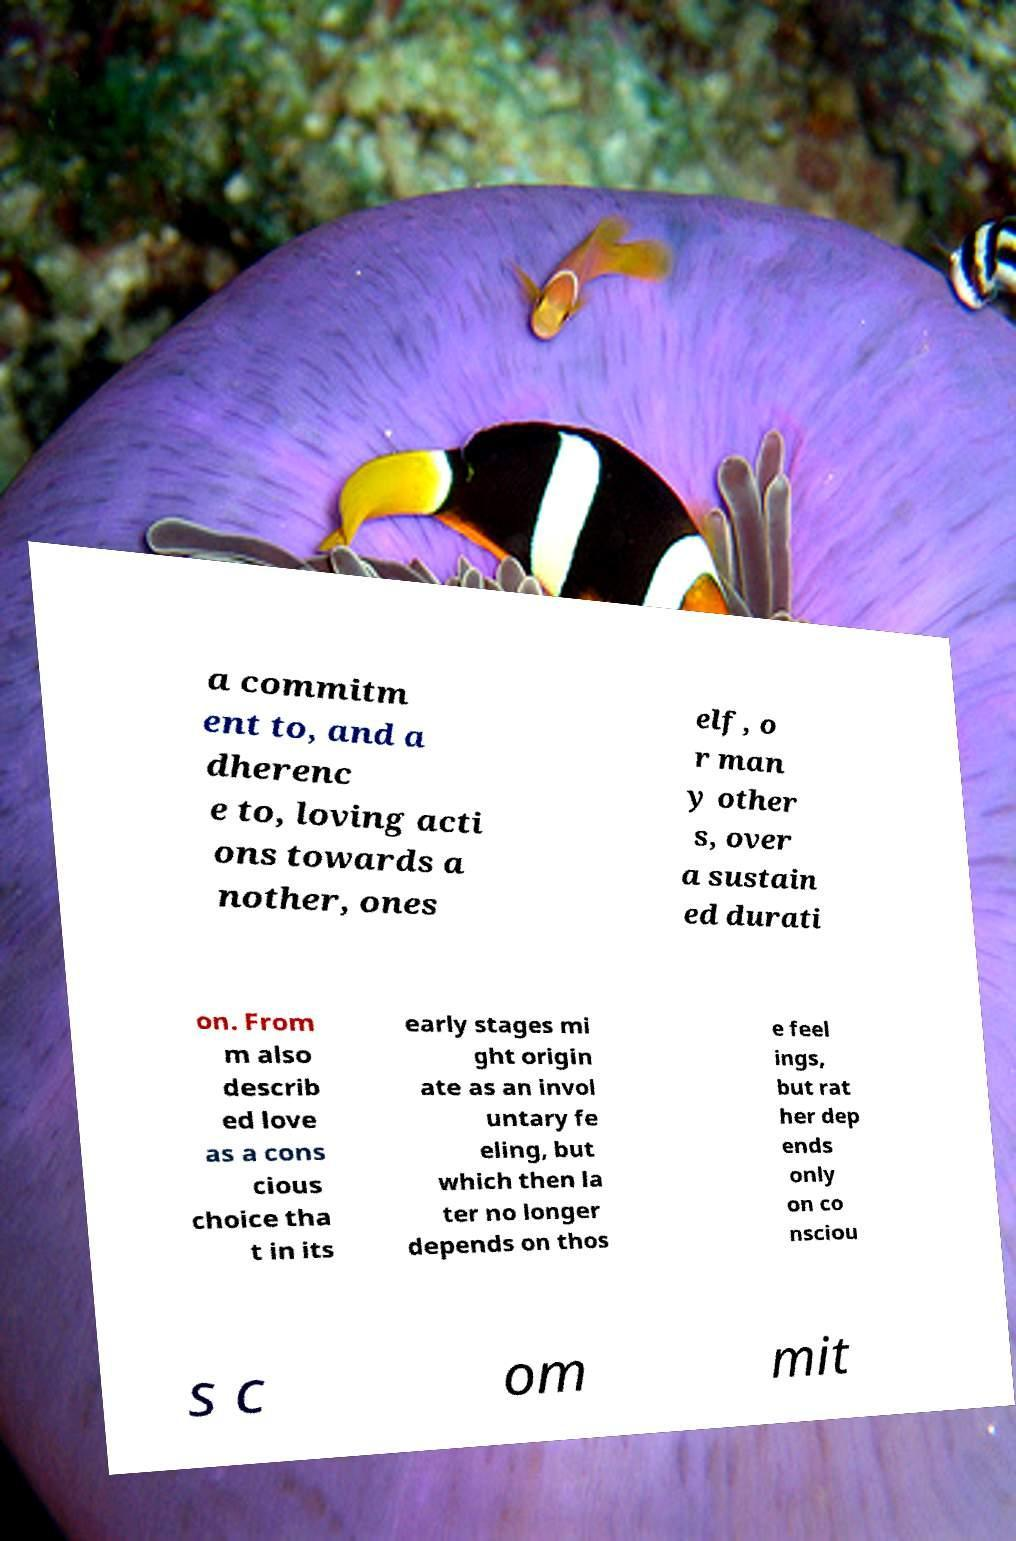Can you accurately transcribe the text from the provided image for me? a commitm ent to, and a dherenc e to, loving acti ons towards a nother, ones elf, o r man y other s, over a sustain ed durati on. From m also describ ed love as a cons cious choice tha t in its early stages mi ght origin ate as an invol untary fe eling, but which then la ter no longer depends on thos e feel ings, but rat her dep ends only on co nsciou s c om mit 